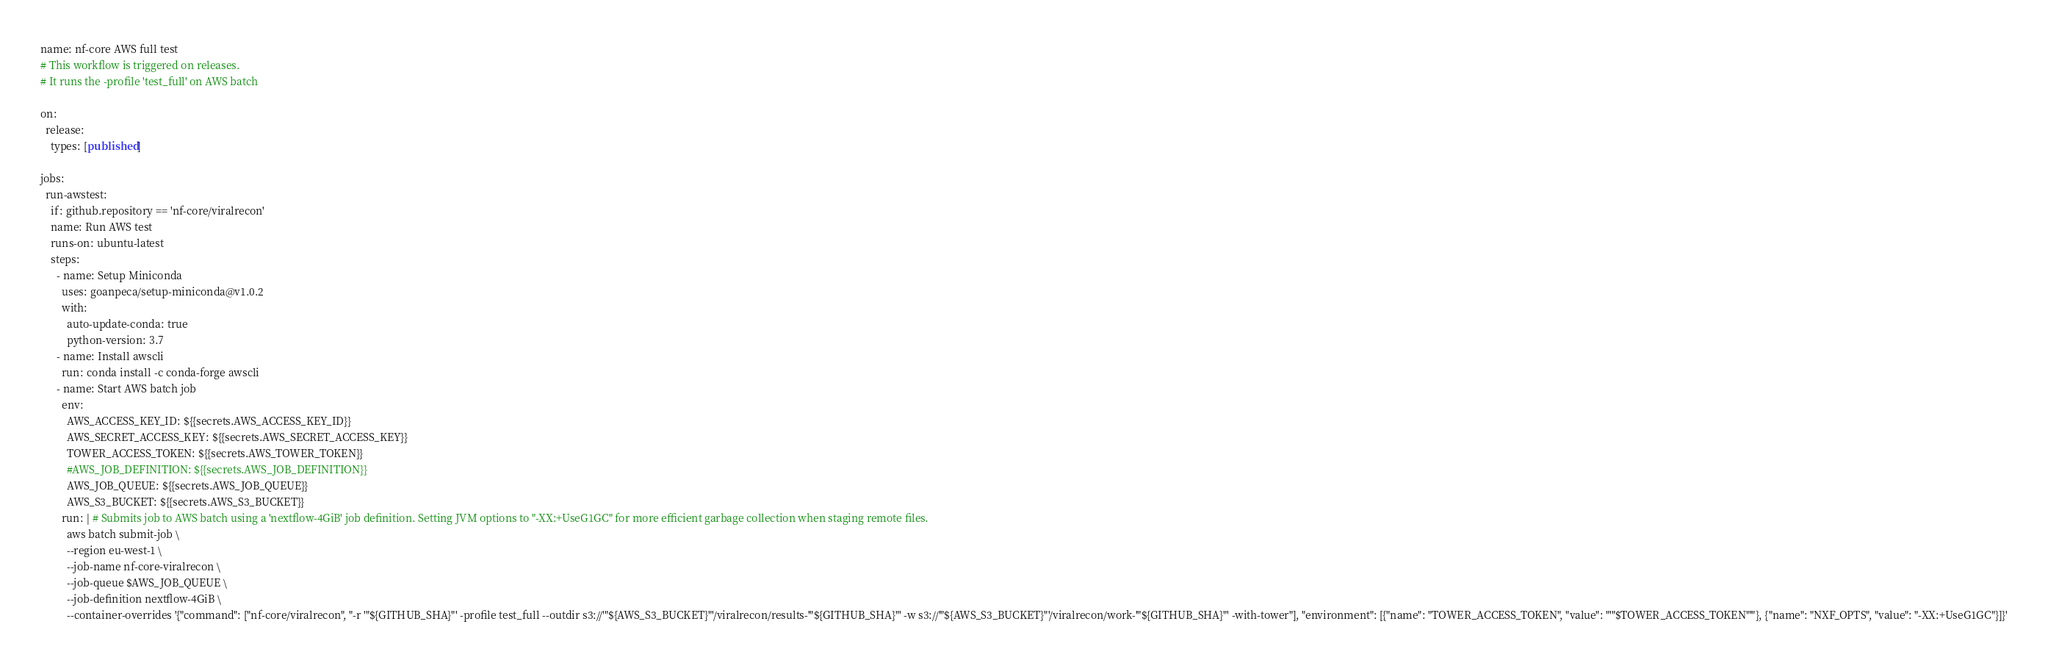<code> <loc_0><loc_0><loc_500><loc_500><_YAML_>name: nf-core AWS full test
# This workflow is triggered on releases.
# It runs the -profile 'test_full' on AWS batch

on:
  release:
    types: [published]

jobs:
  run-awstest:
    if: github.repository == 'nf-core/viralrecon'
    name: Run AWS test
    runs-on: ubuntu-latest
    steps:
      - name: Setup Miniconda
        uses: goanpeca/setup-miniconda@v1.0.2
        with:
          auto-update-conda: true
          python-version: 3.7
      - name: Install awscli
        run: conda install -c conda-forge awscli
      - name: Start AWS batch job
        env:
          AWS_ACCESS_KEY_ID: ${{secrets.AWS_ACCESS_KEY_ID}}
          AWS_SECRET_ACCESS_KEY: ${{secrets.AWS_SECRET_ACCESS_KEY}}
          TOWER_ACCESS_TOKEN: ${{secrets.AWS_TOWER_TOKEN}}
          #AWS_JOB_DEFINITION: ${{secrets.AWS_JOB_DEFINITION}}
          AWS_JOB_QUEUE: ${{secrets.AWS_JOB_QUEUE}}
          AWS_S3_BUCKET: ${{secrets.AWS_S3_BUCKET}}
        run: | # Submits job to AWS batch using a 'nextflow-4GiB' job definition. Setting JVM options to "-XX:+UseG1GC" for more efficient garbage collection when staging remote files.
          aws batch submit-job \
          --region eu-west-1 \
          --job-name nf-core-viralrecon \
          --job-queue $AWS_JOB_QUEUE \
          --job-definition nextflow-4GiB \
          --container-overrides '{"command": ["nf-core/viralrecon", "-r '"${GITHUB_SHA}"' -profile test_full --outdir s3://'"${AWS_S3_BUCKET}"'/viralrecon/results-'"${GITHUB_SHA}"' -w s3://'"${AWS_S3_BUCKET}"'/viralrecon/work-'"${GITHUB_SHA}"' -with-tower"], "environment": [{"name": "TOWER_ACCESS_TOKEN", "value": "'"$TOWER_ACCESS_TOKEN"'"}, {"name": "NXF_OPTS", "value": "-XX:+UseG1GC"}]}'</code> 